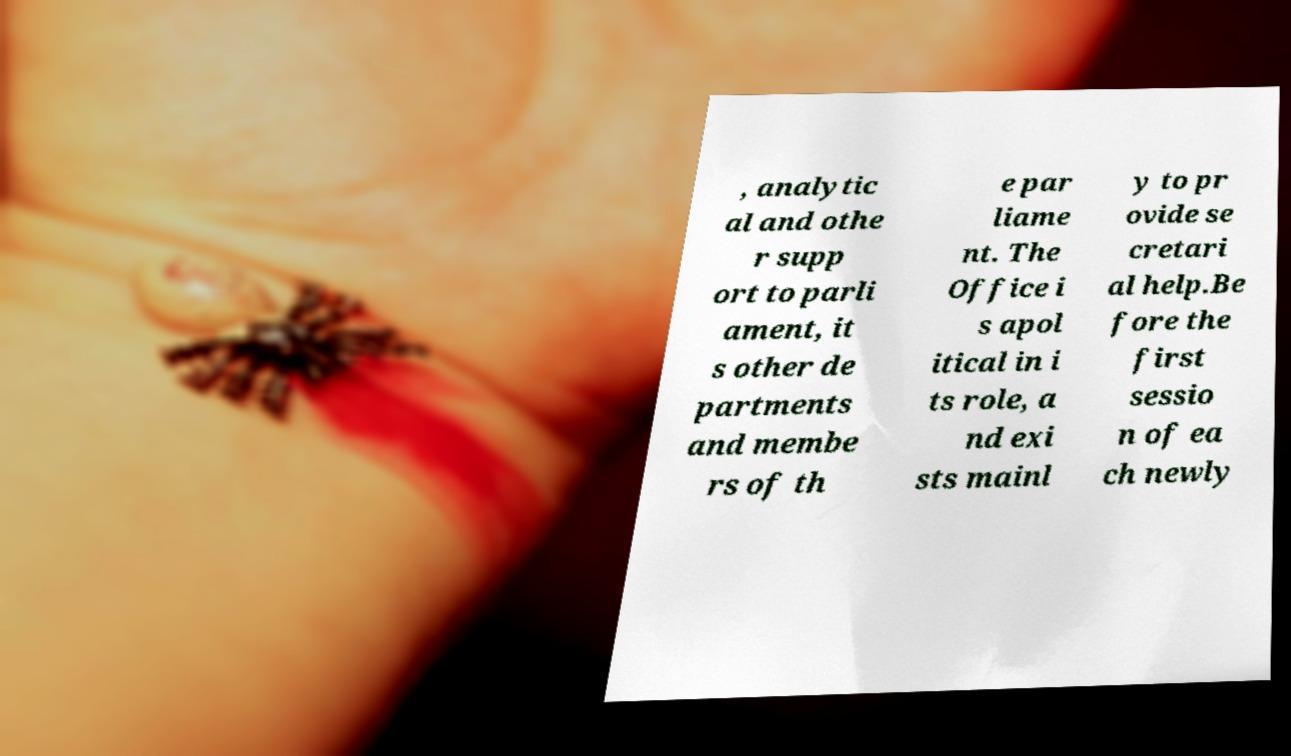Can you read and provide the text displayed in the image?This photo seems to have some interesting text. Can you extract and type it out for me? , analytic al and othe r supp ort to parli ament, it s other de partments and membe rs of th e par liame nt. The Office i s apol itical in i ts role, a nd exi sts mainl y to pr ovide se cretari al help.Be fore the first sessio n of ea ch newly 